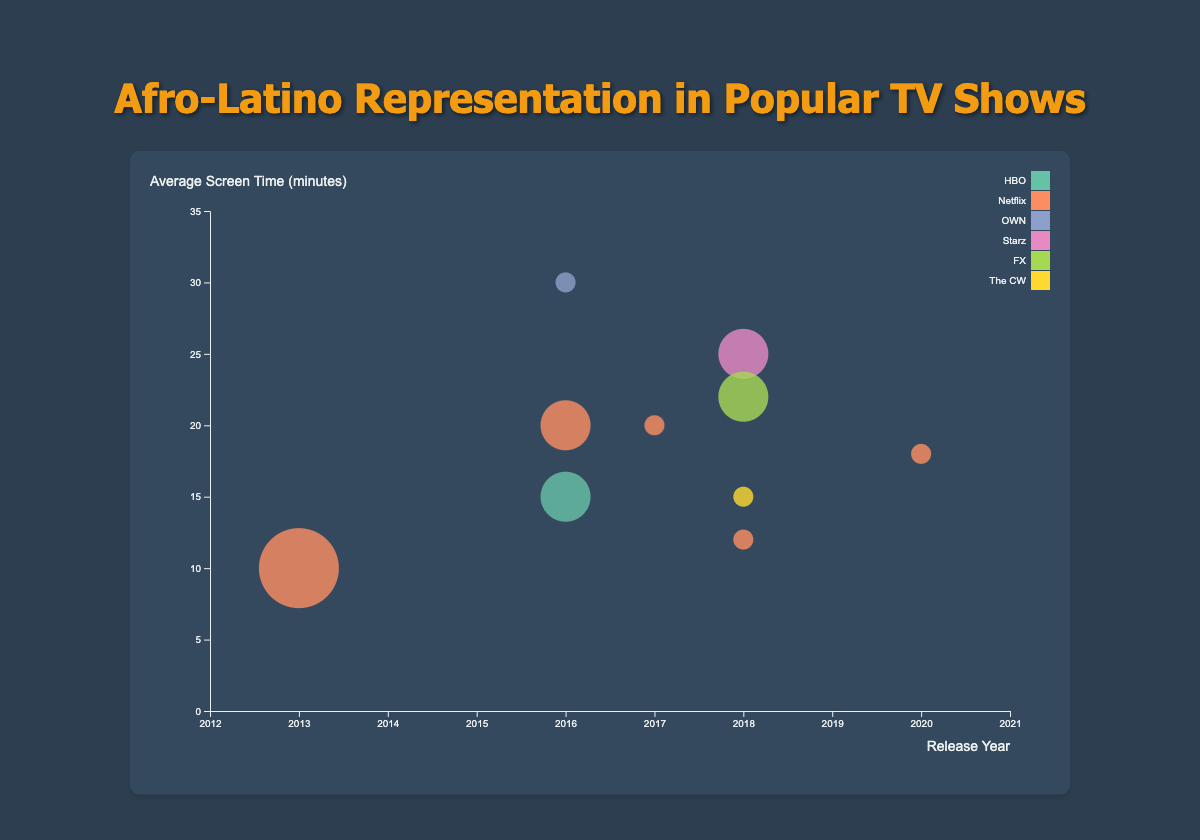Which TV show has the highest audience score? To find the highest audience score, look for the largest percentage value on the tooltip or closest data point when hovering over the bubbles. "Insecure" and "Pose" both have an audience score of 96%.
Answer: Insecure, Pose Which show features the most Afro-Latino characters? Hover over the bubbles to check the "Afro-Latino Characters" information. "Orange is the New Black" has the highest number with 3 characters.
Answer: Orange is the New Black What is the relationship between the release year and the average screen time for "Queen Sugar"? Locate the bubble for "Queen Sugar" by its tooltip. It was released in 2016 and has an average screen time of 30 minutes.
Answer: Released in 2016 with 30 minutes of average screen time Which shows are represented by the largest bubbles? The size of the bubbles corresponds to the number of Afro-Latino characters. Look for the largest bubbles, "Orange is the New Black" has the largest bubble representing 3 characters.
Answer: Orange is the New Black Which show on Netflix released in 2018 has an average screen time of 12 minutes? Check the bubbles colored similarly (all Netflix shows), and hover to find "On My Block" with a release in 2018 and 12 minutes of average screen time.
Answer: On My Block Compare the average screen time of the show "Pose" and "Black Lightning." Find and hover over the bubbles for each show. "Pose" has an average screen time of 22 minutes, while "Black Lightning" has 15 minutes.
Answer: Pose: 22 mins, Black Lightning: 15 mins Which TV show on HBO features Afro-Latino characters and what is their average screen time? Look for the HBO-colored bubble, which is "Insecure". It features 2 Afro-Latino characters with an average screen time of 15 minutes.
Answer: Insecure, 15 minutes How many shows were released in 2018 with at least 2 Afro-Latino characters? Identify the bubbles corresponding to 2018 and check the Afro-Latino characters. "Pose" and "Vida" both have 2 characters and were released in 2018.
Answer: 2 shows Calculate the difference in audience scores between "One Day at a Time" and "The Get Down." Hover over each bubble to see their audience scores: "One Day at a Time" has 89%, and "The Get Down" has 81%, resulting in a difference of 8%.
Answer: 8% Which show has the shortest average screen time and how many Afro-Latino characters does it have? Hover over all bubbles to find that "Orange is the New Black" has the shortest average screen time of 10 minutes and features 3 Afro-Latino characters.
Answer: Orange is the New Black, 3 characters 